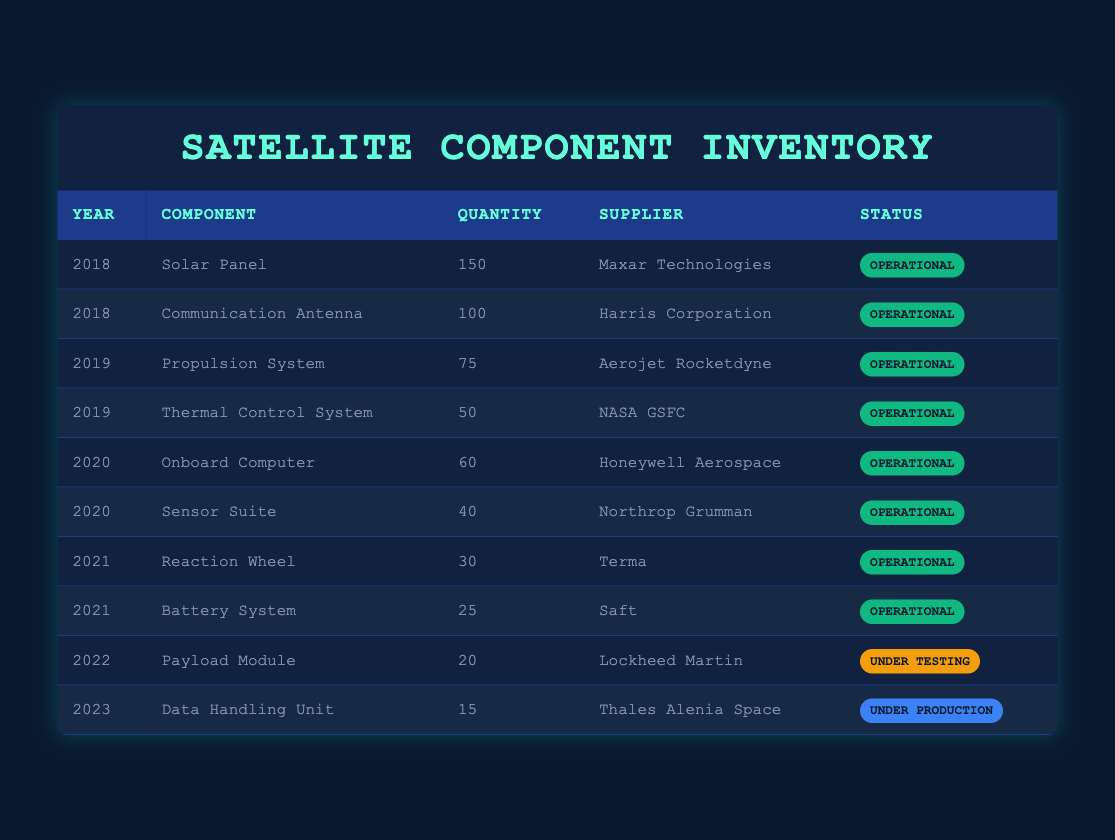What is the total quantity of components listed in 2019? The components listed for 2019 are the Propulsion System with a quantity of 75 and the Thermal Control System with a quantity of 50. Summing these gives 75 + 50 = 125.
Answer: 125 Which supplier provided the most components in 2018? The suppliers in 2018 are Maxar Technologies with 150 Solar Panels and Harris Corporation with 100 Communication Antennas. Maxar Technologies has the higher number of components.
Answer: Maxar Technologies Are all components from 2021 operational? The components from 2021 are the Reaction Wheel with a quantity of 30 and the Battery System with a quantity of 25, both of which have a status of operational. Therefore, all components from 2021 are operational.
Answer: Yes What is the average quantity of components for the years 2020 and 2022? The quantities for 2020 are 60 (Onboard Computer) and 40 (Sensor Suite), and the quantity for 2022 is 20 (Payload Module). The total is 60 + 40 + 20 = 120. There are 3 components, so the average quantity is 120 / 3 = 40.
Answer: 40 Which component has the lowest quantity in the inventory, and what is its status? The components with the lowest quantity are the Data Handling Unit with 15 in 2023, which is listed as Under Production, and the Payload Module with 20 in 2022, which is Under Testing. The Data Handling Unit has the lowest quantity of 15.
Answer: Data Handling Unit, Under Production How many total components are operational across all years? The operational components are: Solar Panel (150), Communication Antenna (100), Propulsion System (75), Thermal Control System (50), Onboard Computer (60), Sensor Suite (40), Reaction Wheel (30), and Battery System (25). Adding these gives a total of 150 + 100 + 75 + 50 + 60 + 40 + 30 + 25 = 530.
Answer: 530 Which year saw the least number of components listed in the inventory? The years and their quantities include: 2018 (250), 2019 (125), 2020 (100), 2021 (55), 2022 (20), and 2023 (15). The year with the least total is 2023 with only 15 components.
Answer: 2023 Is there any component from 2022 that is operational? The only component from 2022 is the Payload Module, which is listed as Under Testing. Therefore, there are no operational components from 2022.
Answer: No 